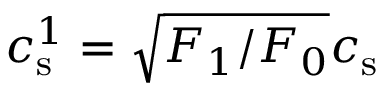<formula> <loc_0><loc_0><loc_500><loc_500>c _ { s } ^ { 1 } = \sqrt { F _ { 1 } / F _ { 0 } } c _ { s }</formula> 